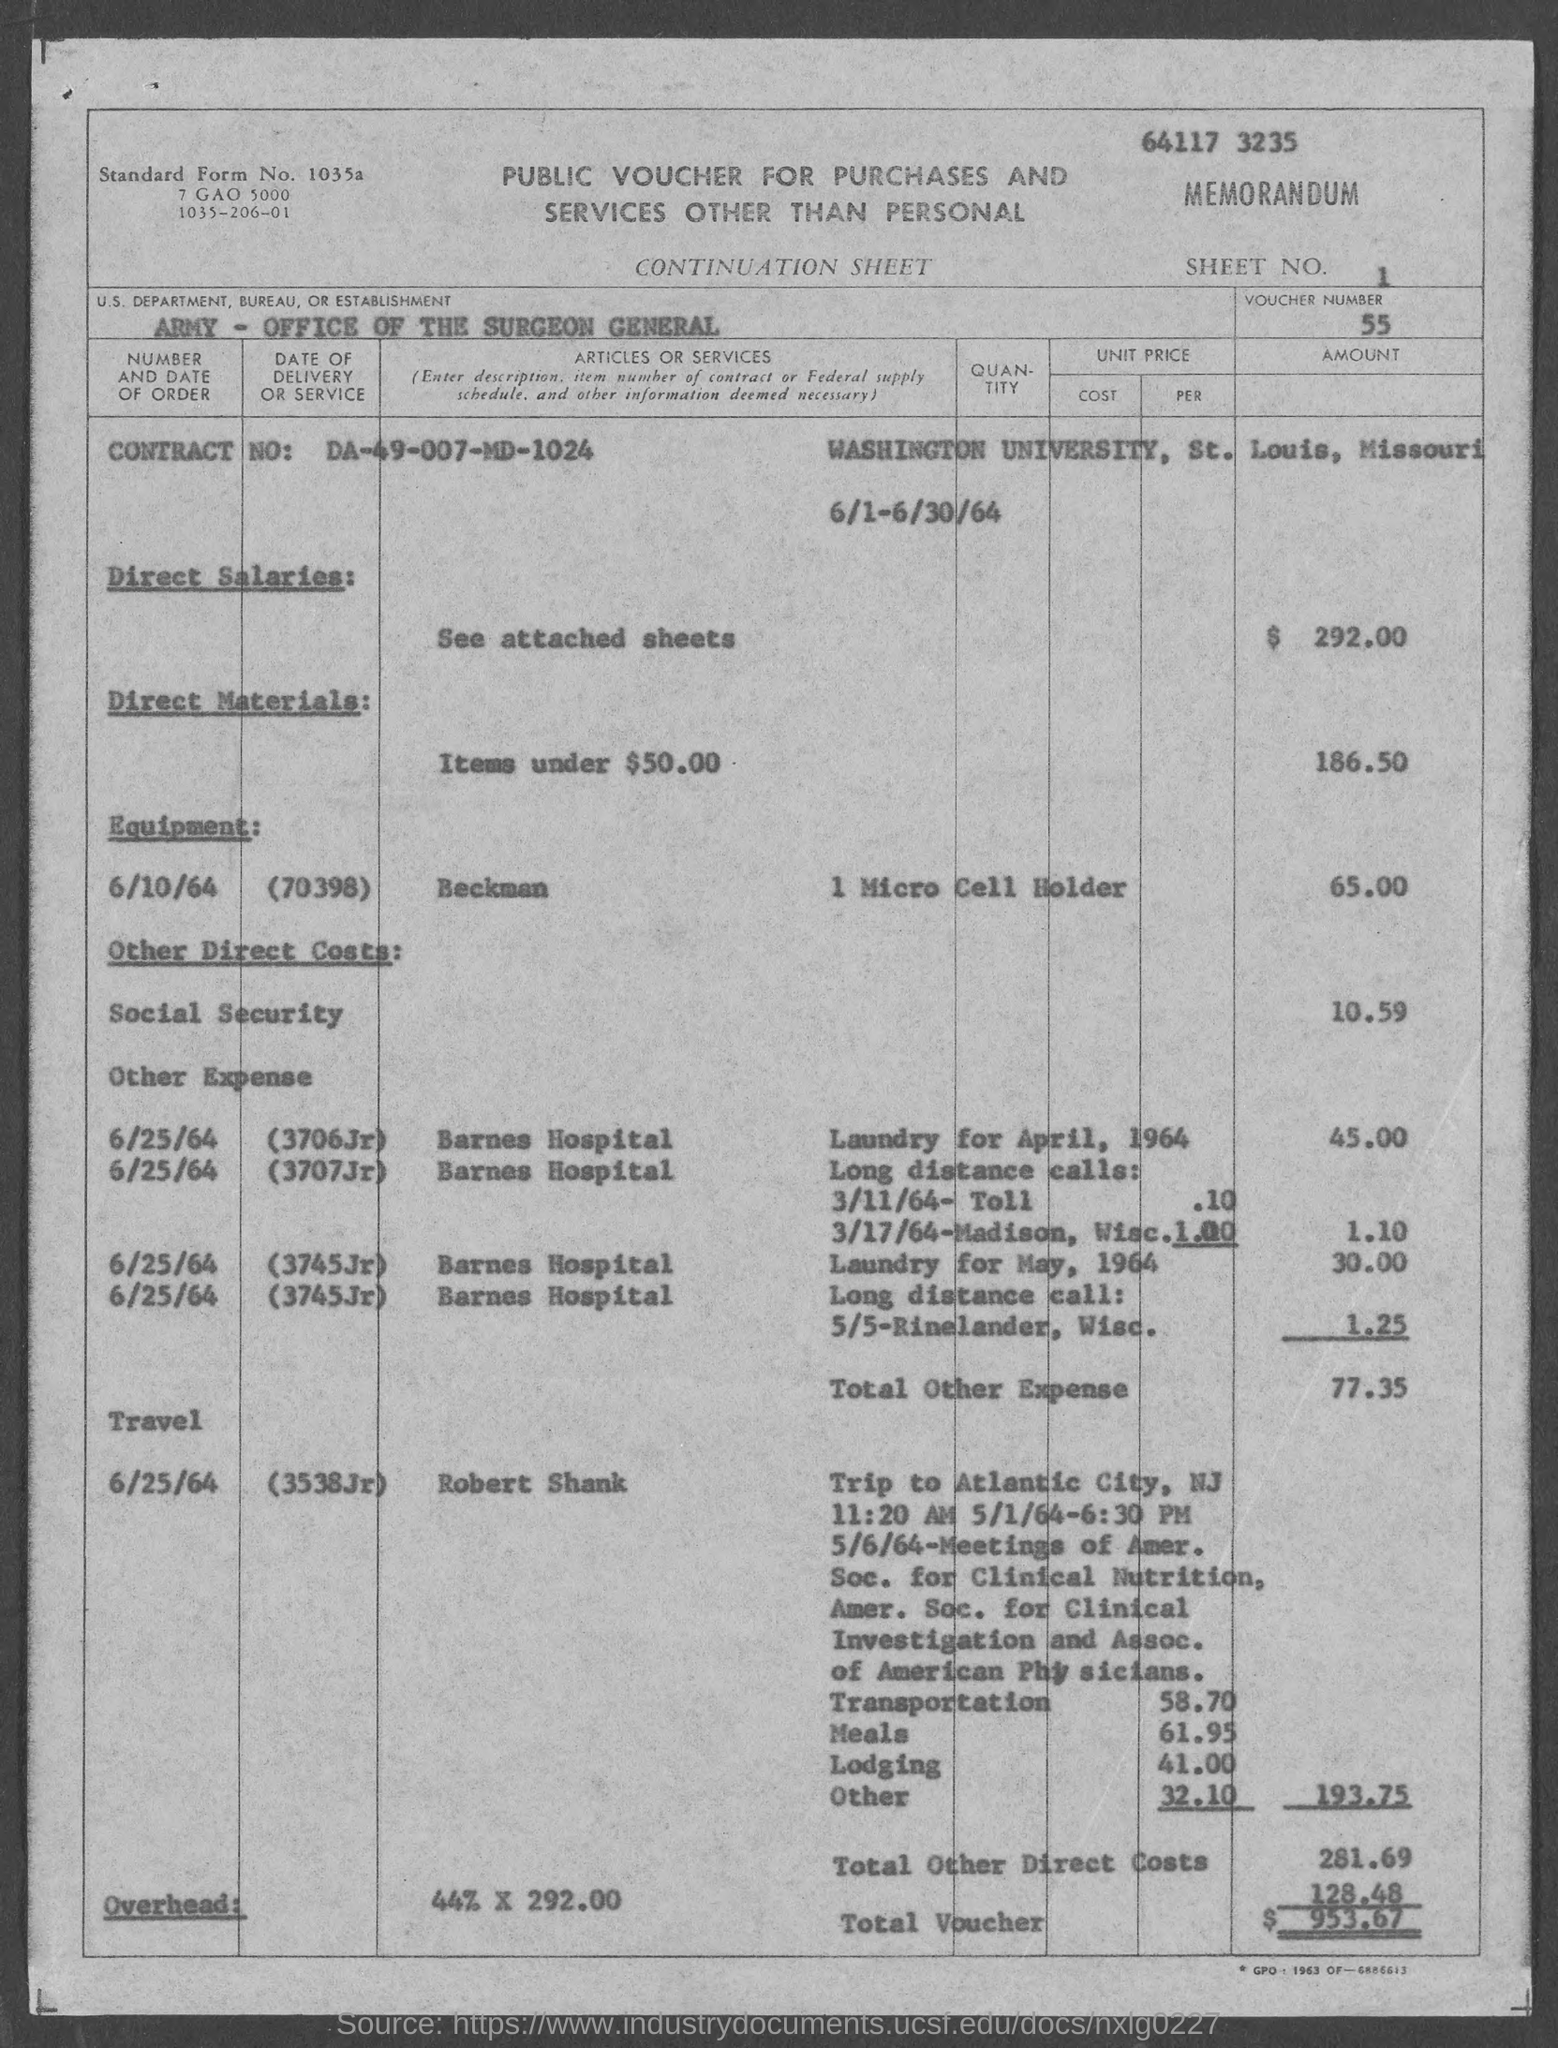Point out several critical features in this image. The amount for direct materials, as mentioned in the provided form, is $186.50. I am not able to understand the context or the question you are asking. Could you please provide me with more information or clarify your question? The total amount of other expenses mentioned in the given form is 77.35.. According to the provided form, the amount of direct salaries is $292.00. The amount of laundry for April, 1964, as mentioned in the given form is 45.00. 